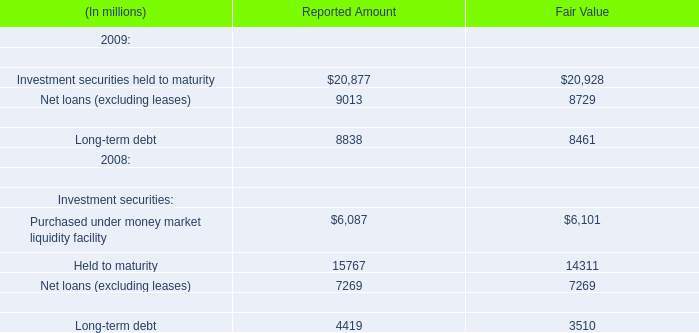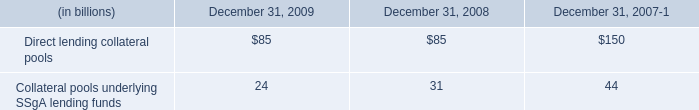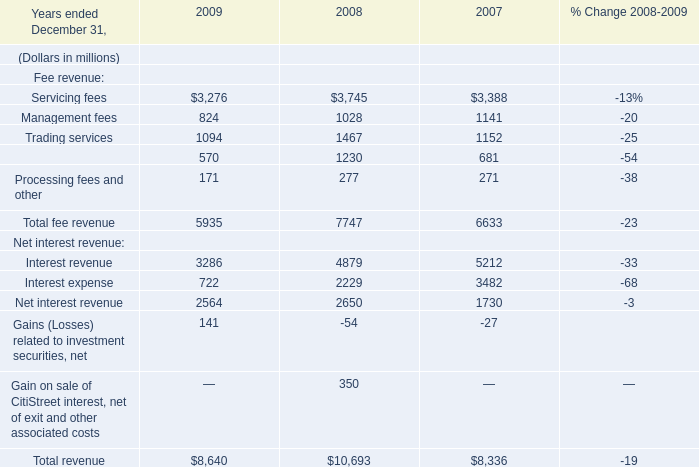In the year with the most Servicing fees for Fee revenue, what is the growth rate of Total fee revenue for Fee revenue? 
Computations: ((5935 - 7747) / 7747)
Answer: -0.2339. 